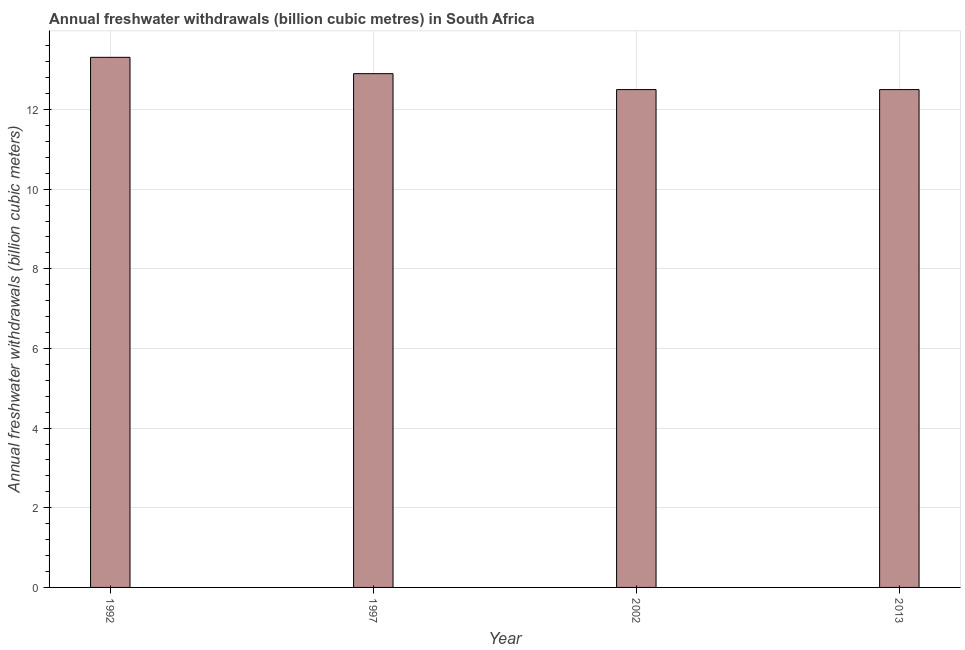What is the title of the graph?
Provide a short and direct response. Annual freshwater withdrawals (billion cubic metres) in South Africa. What is the label or title of the Y-axis?
Ensure brevity in your answer.  Annual freshwater withdrawals (billion cubic meters). What is the annual freshwater withdrawals in 1992?
Your answer should be compact. 13.31. Across all years, what is the maximum annual freshwater withdrawals?
Your response must be concise. 13.31. Across all years, what is the minimum annual freshwater withdrawals?
Offer a terse response. 12.5. In which year was the annual freshwater withdrawals maximum?
Make the answer very short. 1992. In which year was the annual freshwater withdrawals minimum?
Provide a short and direct response. 2002. What is the sum of the annual freshwater withdrawals?
Ensure brevity in your answer.  51.21. What is the average annual freshwater withdrawals per year?
Provide a short and direct response. 12.8. What is the median annual freshwater withdrawals?
Your answer should be very brief. 12.7. In how many years, is the annual freshwater withdrawals greater than 9.2 billion cubic meters?
Offer a terse response. 4. Do a majority of the years between 2002 and 1997 (inclusive) have annual freshwater withdrawals greater than 9.6 billion cubic meters?
Keep it short and to the point. No. What is the ratio of the annual freshwater withdrawals in 1997 to that in 2013?
Offer a terse response. 1.03. Is the annual freshwater withdrawals in 2002 less than that in 2013?
Provide a short and direct response. No. What is the difference between the highest and the second highest annual freshwater withdrawals?
Your answer should be very brief. 0.41. Is the sum of the annual freshwater withdrawals in 1992 and 1997 greater than the maximum annual freshwater withdrawals across all years?
Provide a short and direct response. Yes. What is the difference between the highest and the lowest annual freshwater withdrawals?
Provide a short and direct response. 0.81. How many bars are there?
Offer a terse response. 4. Are all the bars in the graph horizontal?
Provide a short and direct response. No. How many years are there in the graph?
Offer a terse response. 4. Are the values on the major ticks of Y-axis written in scientific E-notation?
Offer a very short reply. No. What is the Annual freshwater withdrawals (billion cubic meters) in 1992?
Offer a terse response. 13.31. What is the Annual freshwater withdrawals (billion cubic meters) in 2002?
Offer a terse response. 12.5. What is the Annual freshwater withdrawals (billion cubic meters) in 2013?
Keep it short and to the point. 12.5. What is the difference between the Annual freshwater withdrawals (billion cubic meters) in 1992 and 1997?
Your answer should be compact. 0.41. What is the difference between the Annual freshwater withdrawals (billion cubic meters) in 1992 and 2002?
Your answer should be very brief. 0.81. What is the difference between the Annual freshwater withdrawals (billion cubic meters) in 1992 and 2013?
Offer a terse response. 0.81. What is the difference between the Annual freshwater withdrawals (billion cubic meters) in 1997 and 2002?
Your answer should be compact. 0.4. What is the difference between the Annual freshwater withdrawals (billion cubic meters) in 1997 and 2013?
Make the answer very short. 0.4. What is the ratio of the Annual freshwater withdrawals (billion cubic meters) in 1992 to that in 1997?
Offer a terse response. 1.03. What is the ratio of the Annual freshwater withdrawals (billion cubic meters) in 1992 to that in 2002?
Make the answer very short. 1.06. What is the ratio of the Annual freshwater withdrawals (billion cubic meters) in 1992 to that in 2013?
Provide a succinct answer. 1.06. What is the ratio of the Annual freshwater withdrawals (billion cubic meters) in 1997 to that in 2002?
Keep it short and to the point. 1.03. What is the ratio of the Annual freshwater withdrawals (billion cubic meters) in 1997 to that in 2013?
Your response must be concise. 1.03. 